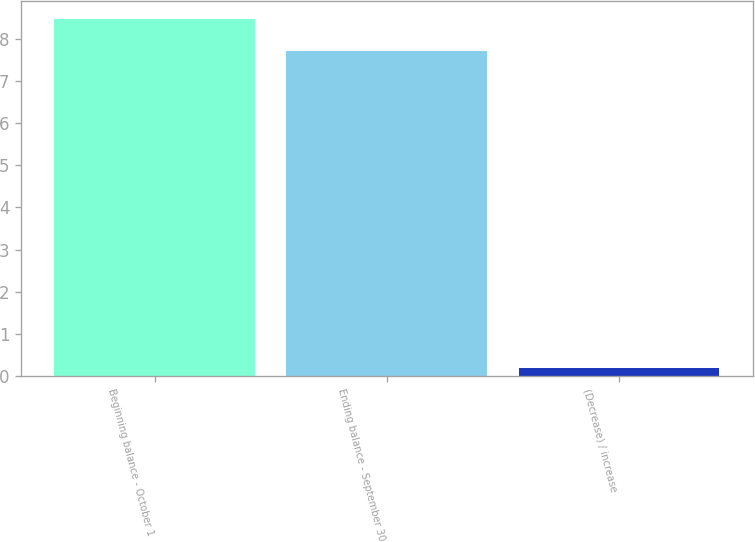Convert chart to OTSL. <chart><loc_0><loc_0><loc_500><loc_500><bar_chart><fcel>Beginning balance - October 1<fcel>Ending balance - September 30<fcel>(Decrease) / increase<nl><fcel>8.47<fcel>7.7<fcel>0.2<nl></chart> 